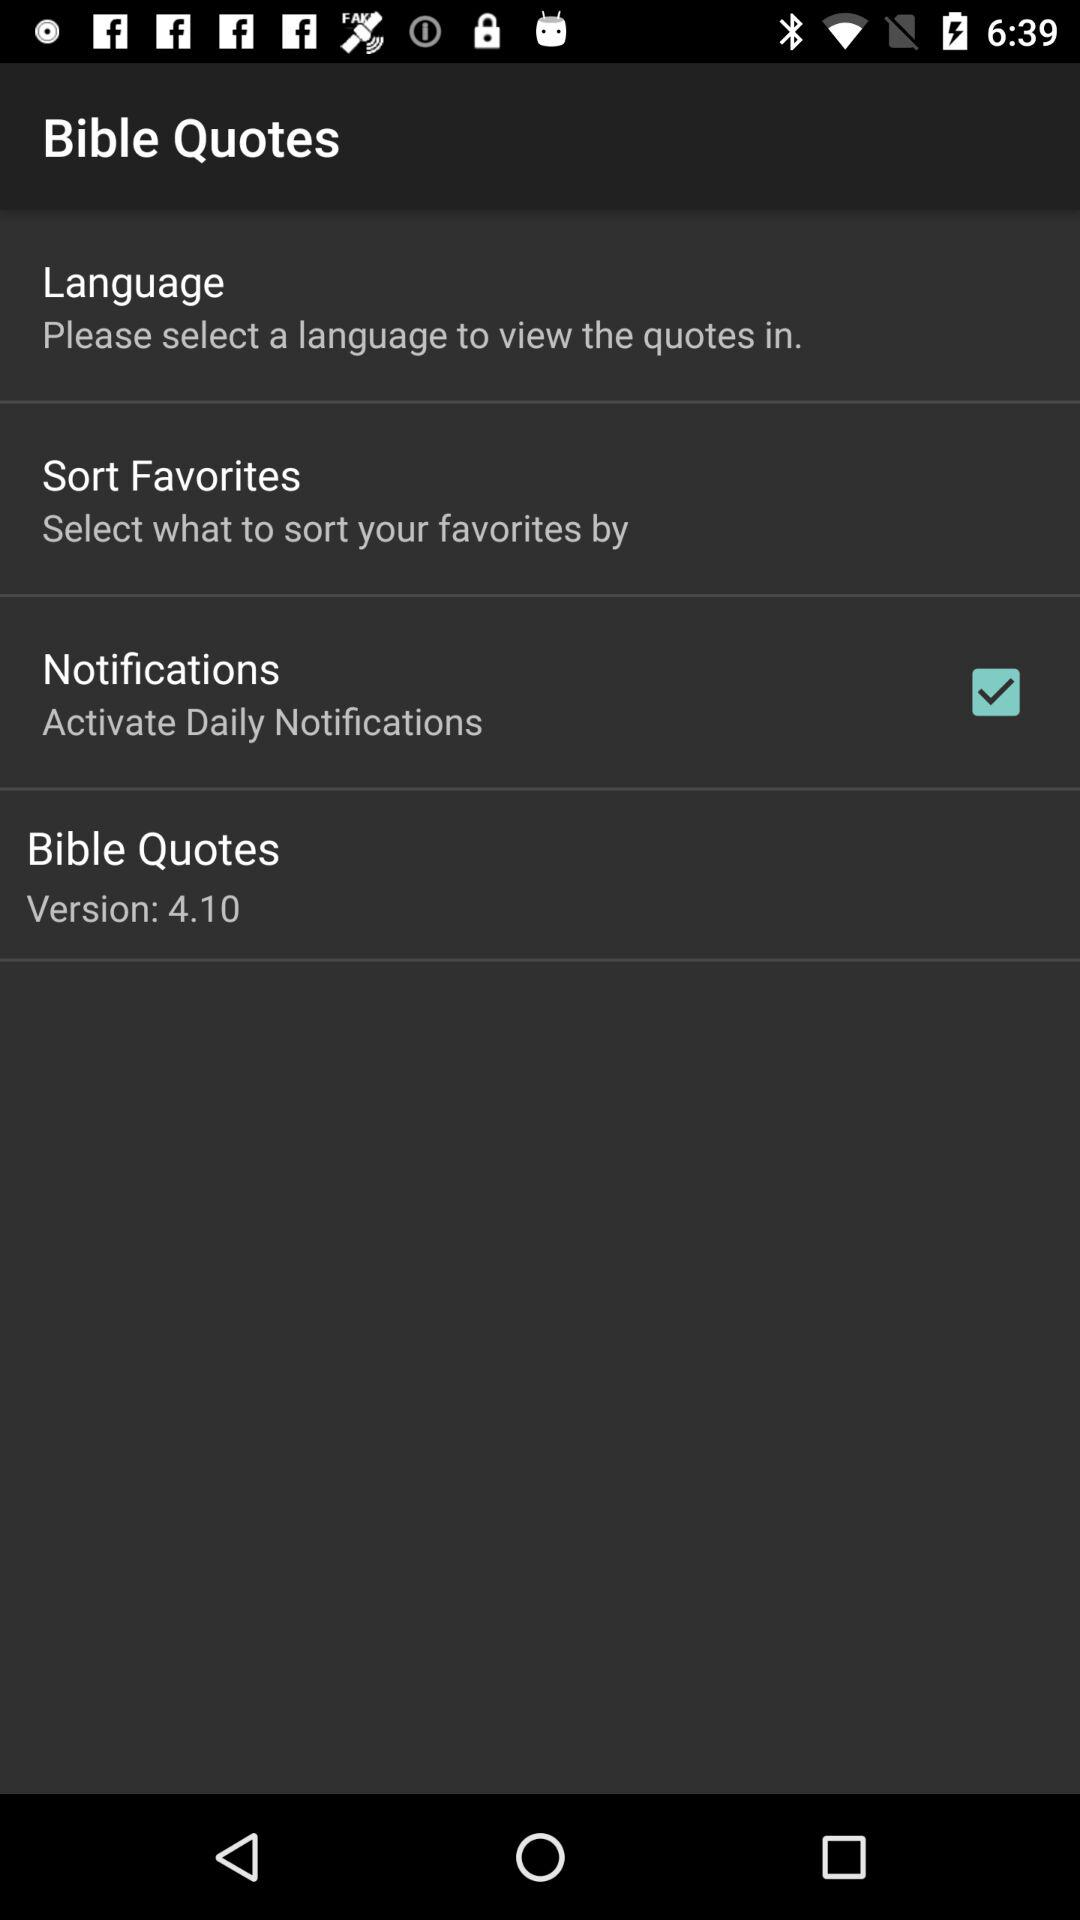What is the status of notifications? The status is on. 